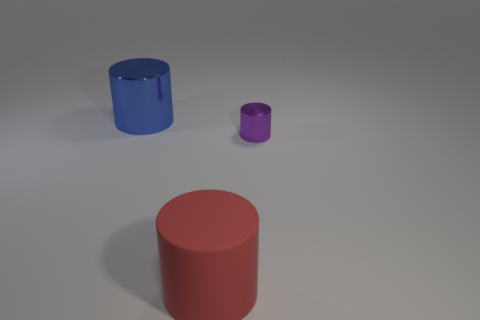There is a purple object that is made of the same material as the big blue thing; what is its size?
Keep it short and to the point. Small. There is a shiny cylinder left of the red matte cylinder; what number of purple things are on the left side of it?
Provide a succinct answer. 0. Is the material of the big object in front of the small purple object the same as the purple cylinder?
Keep it short and to the point. No. Is there any other thing that has the same material as the red cylinder?
Ensure brevity in your answer.  No. There is a shiny thing right of the object that is on the left side of the red thing; what is its size?
Your answer should be very brief. Small. What size is the shiny cylinder in front of the object that is behind the shiny cylinder right of the large red rubber cylinder?
Your answer should be very brief. Small. How many other things are there of the same color as the small thing?
Your response must be concise. 0. Is the size of the thing that is behind the purple object the same as the red matte cylinder?
Offer a terse response. Yes. Is the material of the cylinder behind the small purple metallic cylinder the same as the object to the right of the matte cylinder?
Your answer should be compact. Yes. Is there another red matte thing that has the same size as the matte thing?
Your answer should be very brief. No. 